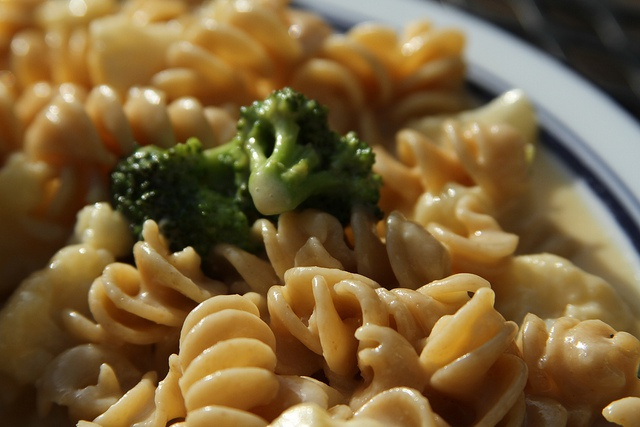Describe the objects in this image and their specific colors. I can see broccoli in tan, black, darkgreen, and olive tones and bowl in tan, lightgray, darkgray, black, and gray tones in this image. 